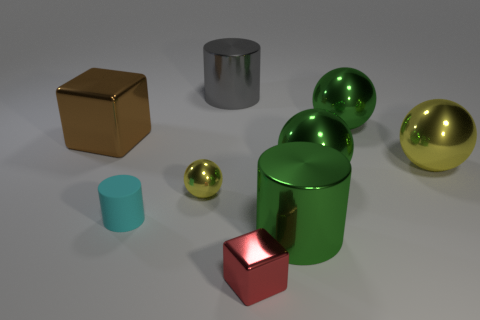Subtract all shiny cylinders. How many cylinders are left? 1 Add 1 matte things. How many objects exist? 10 Subtract 1 blocks. How many blocks are left? 1 Add 2 small cyan matte cylinders. How many small cyan matte cylinders are left? 3 Add 5 small metallic things. How many small metallic things exist? 7 Subtract all red cubes. How many cubes are left? 1 Subtract 0 brown cylinders. How many objects are left? 9 Subtract all cylinders. How many objects are left? 6 Subtract all blue cylinders. Subtract all yellow blocks. How many cylinders are left? 3 Subtract all blue spheres. How many green cylinders are left? 1 